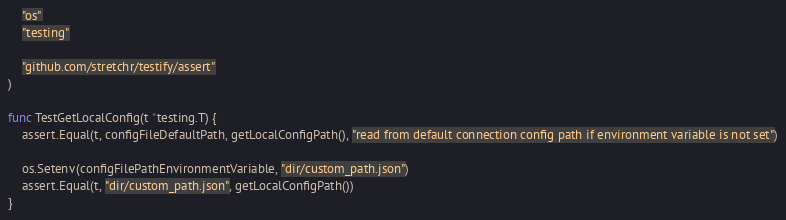Convert code to text. <code><loc_0><loc_0><loc_500><loc_500><_Go_>	"os"
	"testing"

	"github.com/stretchr/testify/assert"
)

func TestGetLocalConfig(t *testing.T) {
	assert.Equal(t, configFileDefaultPath, getLocalConfigPath(), "read from default connection config path if environment variable is not set")

	os.Setenv(configFilePathEnvironmentVariable, "dir/custom_path.json")
	assert.Equal(t, "dir/custom_path.json", getLocalConfigPath())
}
</code> 